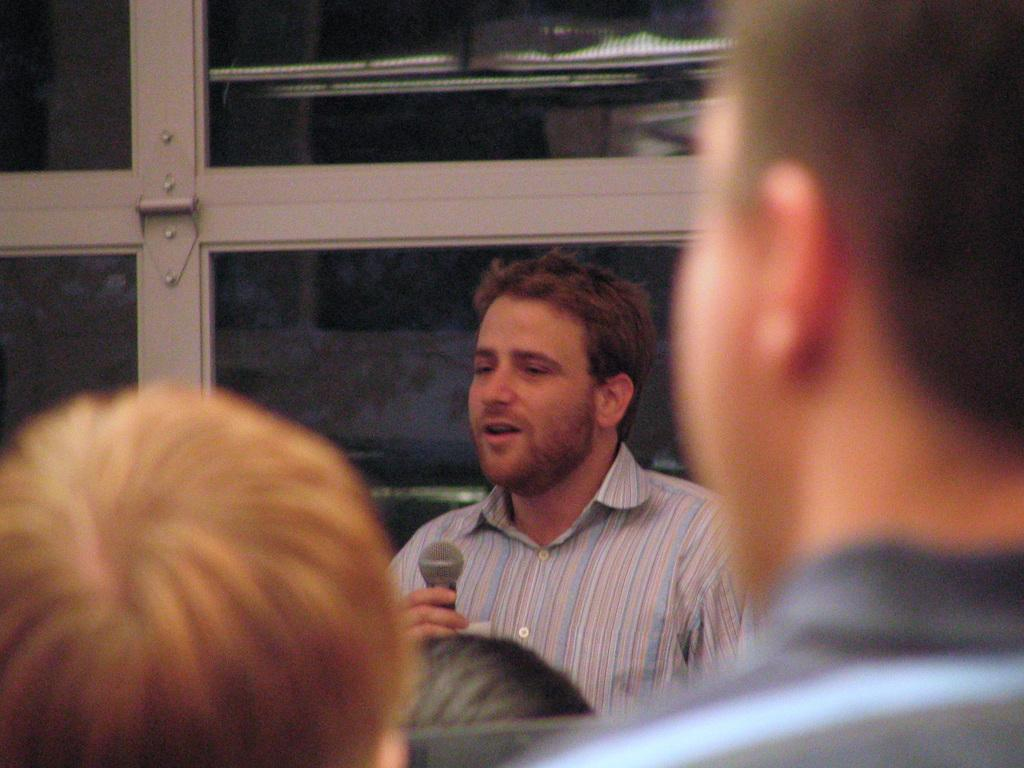What is the man in the image holding? The man is holding a microphone in the image. What are the people at the bottom of the image doing? The people at the bottom of the image are facing backwards. What can be seen at the top of the image? There is a glass window at the top of the image. What type of baseball toy can be seen in the image? There is no baseball toy present in the image. Is there a bathtub visible in the image? There is no bathtub present in the image. 